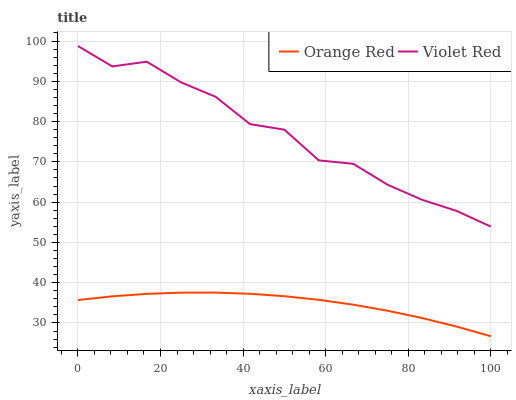Does Orange Red have the minimum area under the curve?
Answer yes or no. Yes. Does Violet Red have the maximum area under the curve?
Answer yes or no. Yes. Does Orange Red have the maximum area under the curve?
Answer yes or no. No. Is Orange Red the smoothest?
Answer yes or no. Yes. Is Violet Red the roughest?
Answer yes or no. Yes. Is Orange Red the roughest?
Answer yes or no. No. Does Orange Red have the lowest value?
Answer yes or no. Yes. Does Violet Red have the highest value?
Answer yes or no. Yes. Does Orange Red have the highest value?
Answer yes or no. No. Is Orange Red less than Violet Red?
Answer yes or no. Yes. Is Violet Red greater than Orange Red?
Answer yes or no. Yes. Does Orange Red intersect Violet Red?
Answer yes or no. No. 